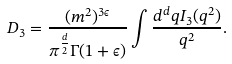<formula> <loc_0><loc_0><loc_500><loc_500>D _ { 3 } = \frac { ( m ^ { 2 } ) ^ { 3 \epsilon } } { { \pi } ^ { \frac { d } { 2 } } \Gamma ( 1 + \epsilon ) } \int \frac { d ^ { d } q I _ { 3 } ( q ^ { 2 } ) } { q ^ { 2 } } .</formula> 